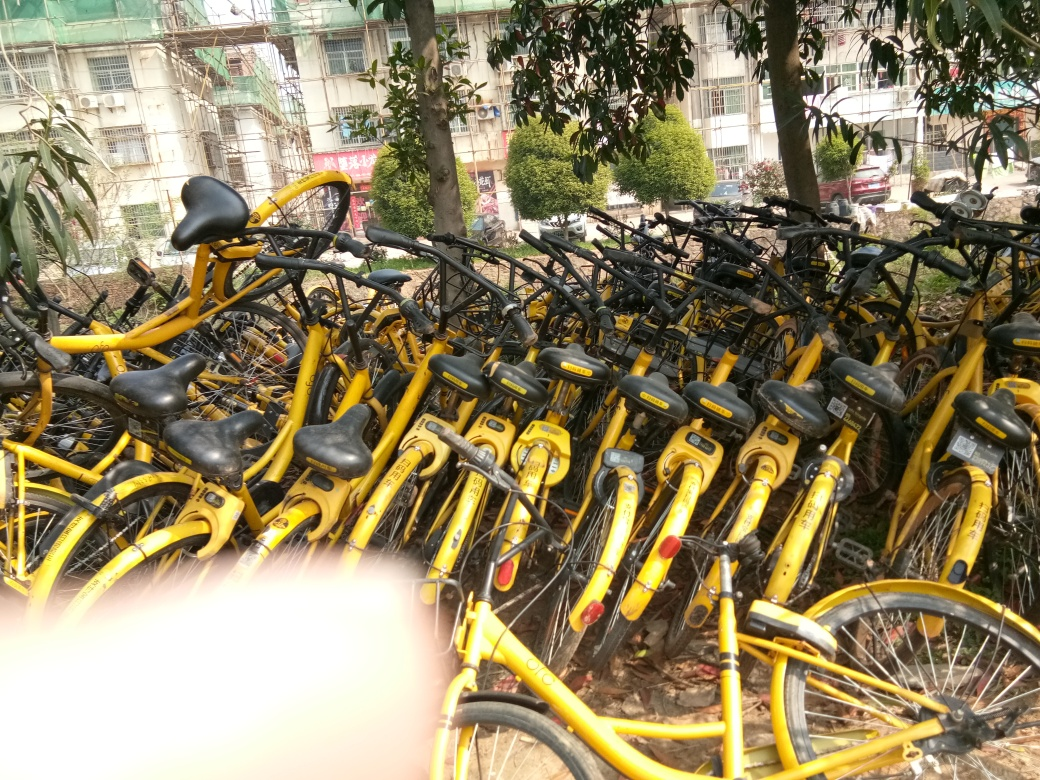Can you estimate how many bicycles are in this image? It's challenging to provide an exact count due to the angle and the overlap, but there seems to be several dozen bicycles visible. The quantity indicates a large scale of operation, possibly a central hub for a bike-sharing program. 